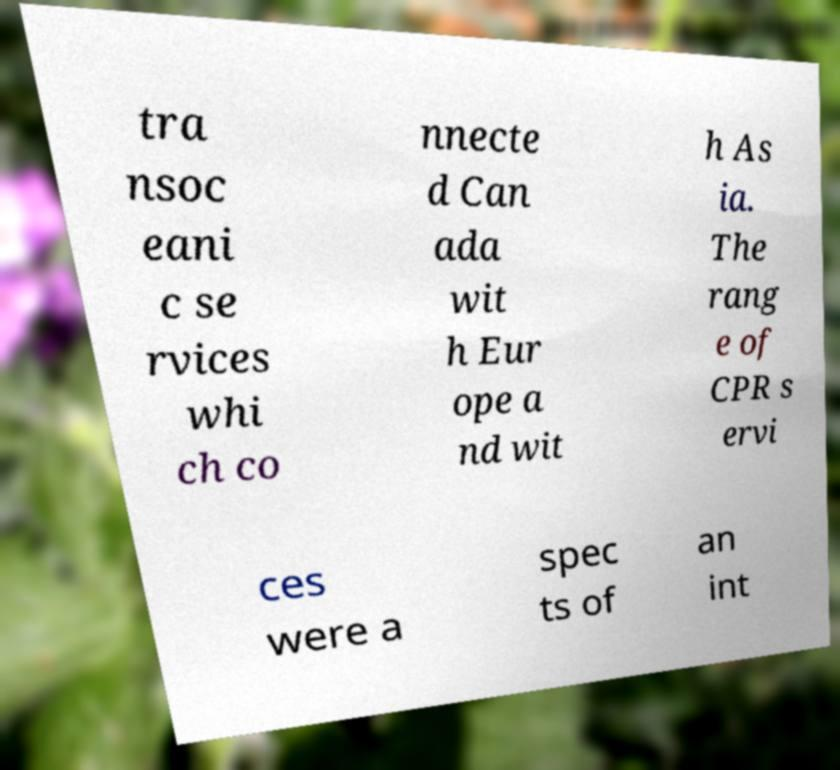Can you accurately transcribe the text from the provided image for me? tra nsoc eani c se rvices whi ch co nnecte d Can ada wit h Eur ope a nd wit h As ia. The rang e of CPR s ervi ces were a spec ts of an int 